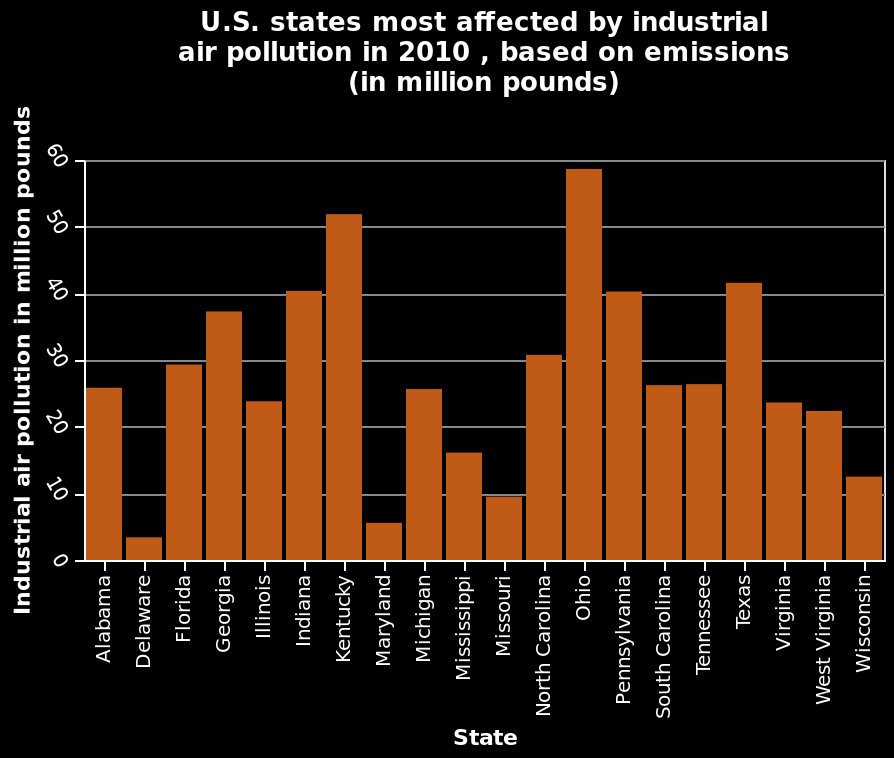<image>
What is plotted on the y-axis of the bar graph? The y-axis plots Industrial air pollution in million pounds with a linear scale ranging from 0 to 60. Which state had the highest industrial air pollution in 2010 according to the bar graph? The bar graph does not provide the specific state with the highest industrial air pollution in 2010. It only depicts the relative rankings of U.S. states based on emissions in million pounds. please enumerates aspects of the construction of the chart This is a bar graph titled U.S. states most affected by industrial air pollution in 2010 , based on emissions (in million pounds). The y-axis plots Industrial air pollution in million pounds with a linear scale with a minimum of 0 and a maximum of 60. A categorical scale with Alabama on one end and Wisconsin at the other can be found on the x-axis, labeled State. What is plotted on the x-axis of the bar graph? The x-axis represents the U.S. states and is labeled as "State". It ranges from Alabama to Wisconsin. 